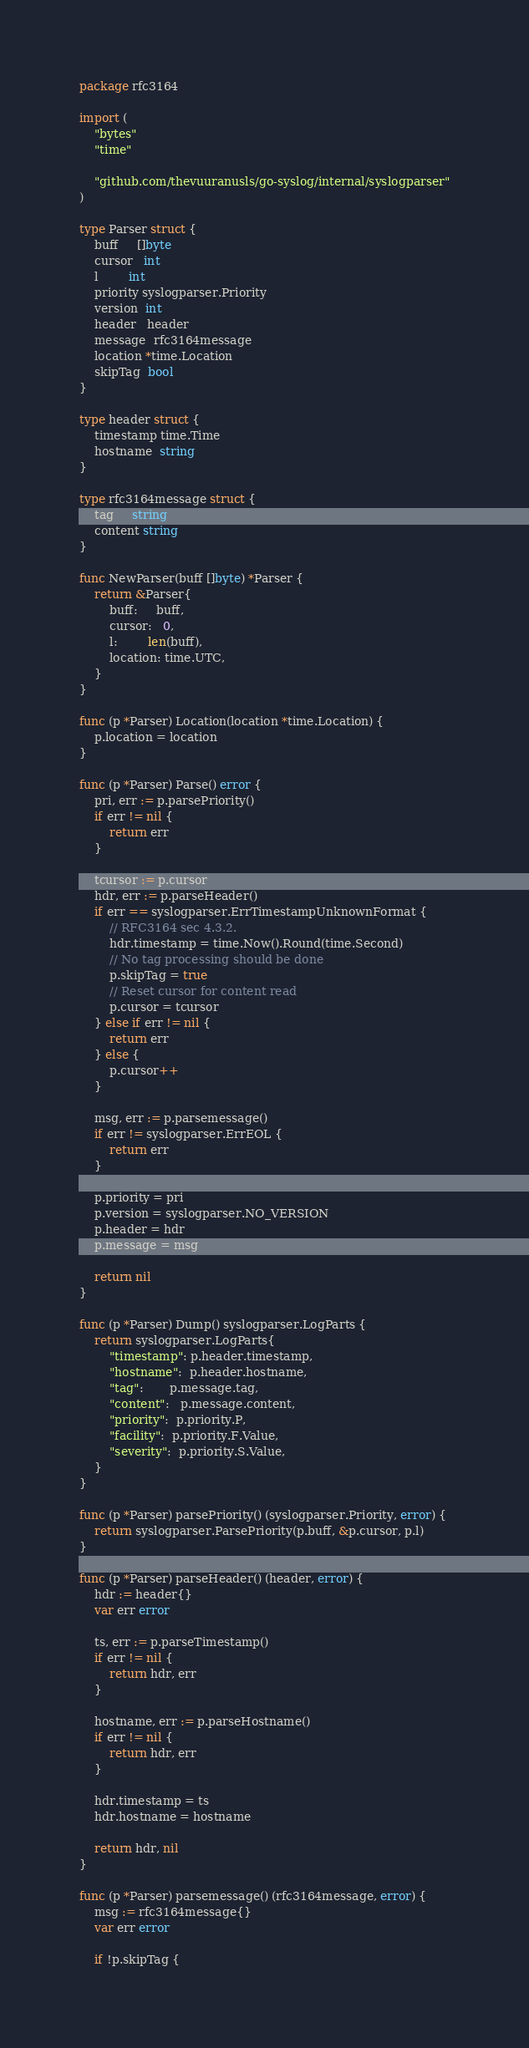<code> <loc_0><loc_0><loc_500><loc_500><_Go_>package rfc3164

import (
	"bytes"
	"time"

	"github.com/thevuuranusls/go-syslog/internal/syslogparser"
)

type Parser struct {
	buff     []byte
	cursor   int
	l        int
	priority syslogparser.Priority
	version  int
	header   header
	message  rfc3164message
	location *time.Location
	skipTag  bool
}

type header struct {
	timestamp time.Time
	hostname  string
}

type rfc3164message struct {
	tag     string
	content string
}

func NewParser(buff []byte) *Parser {
	return &Parser{
		buff:     buff,
		cursor:   0,
		l:        len(buff),
		location: time.UTC,
	}
}

func (p *Parser) Location(location *time.Location) {
	p.location = location
}

func (p *Parser) Parse() error {
	pri, err := p.parsePriority()
	if err != nil {
		return err
	}

	tcursor := p.cursor
	hdr, err := p.parseHeader()
	if err == syslogparser.ErrTimestampUnknownFormat {
		// RFC3164 sec 4.3.2.
		hdr.timestamp = time.Now().Round(time.Second)
		// No tag processing should be done
		p.skipTag = true
		// Reset cursor for content read
		p.cursor = tcursor
	} else if err != nil {
		return err
	} else {
		p.cursor++
	}

	msg, err := p.parsemessage()
	if err != syslogparser.ErrEOL {
		return err
	}

	p.priority = pri
	p.version = syslogparser.NO_VERSION
	p.header = hdr
	p.message = msg

	return nil
}

func (p *Parser) Dump() syslogparser.LogParts {
	return syslogparser.LogParts{
		"timestamp": p.header.timestamp,
		"hostname":  p.header.hostname,
		"tag":       p.message.tag,
		"content":   p.message.content,
		"priority":  p.priority.P,
		"facility":  p.priority.F.Value,
		"severity":  p.priority.S.Value,
	}
}

func (p *Parser) parsePriority() (syslogparser.Priority, error) {
	return syslogparser.ParsePriority(p.buff, &p.cursor, p.l)
}

func (p *Parser) parseHeader() (header, error) {
	hdr := header{}
	var err error

	ts, err := p.parseTimestamp()
	if err != nil {
		return hdr, err
	}

	hostname, err := p.parseHostname()
	if err != nil {
		return hdr, err
	}

	hdr.timestamp = ts
	hdr.hostname = hostname

	return hdr, nil
}

func (p *Parser) parsemessage() (rfc3164message, error) {
	msg := rfc3164message{}
	var err error

	if !p.skipTag {</code> 